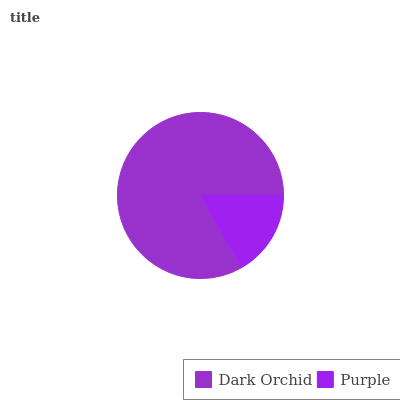Is Purple the minimum?
Answer yes or no. Yes. Is Dark Orchid the maximum?
Answer yes or no. Yes. Is Purple the maximum?
Answer yes or no. No. Is Dark Orchid greater than Purple?
Answer yes or no. Yes. Is Purple less than Dark Orchid?
Answer yes or no. Yes. Is Purple greater than Dark Orchid?
Answer yes or no. No. Is Dark Orchid less than Purple?
Answer yes or no. No. Is Dark Orchid the high median?
Answer yes or no. Yes. Is Purple the low median?
Answer yes or no. Yes. Is Purple the high median?
Answer yes or no. No. Is Dark Orchid the low median?
Answer yes or no. No. 